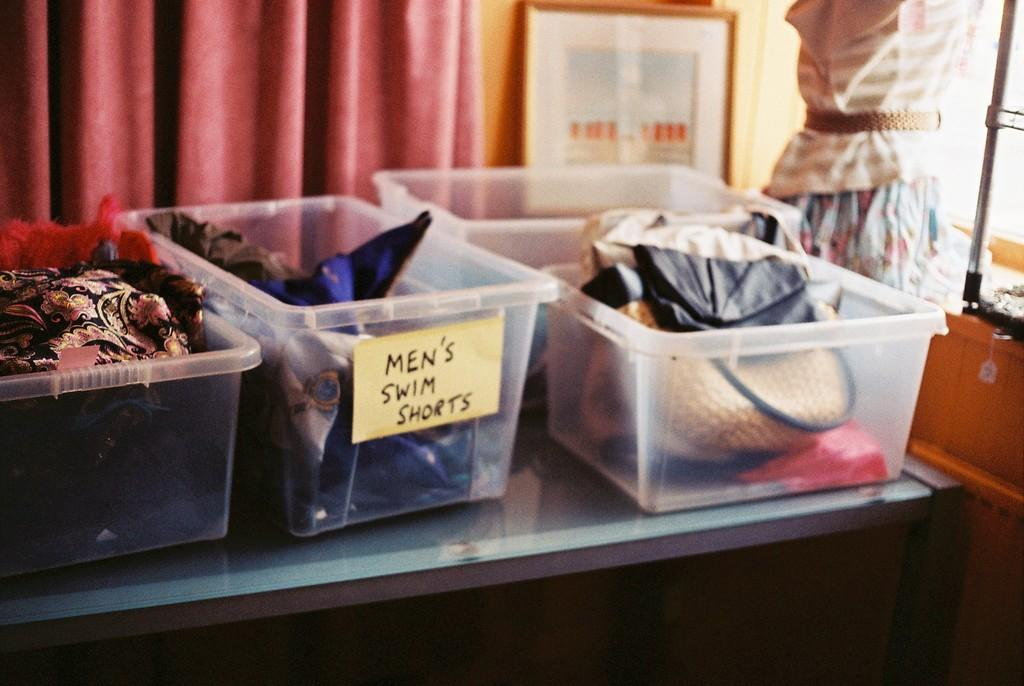<image>
Present a compact description of the photo's key features. Small containers with one that says Men's Swim Shorts on it. 